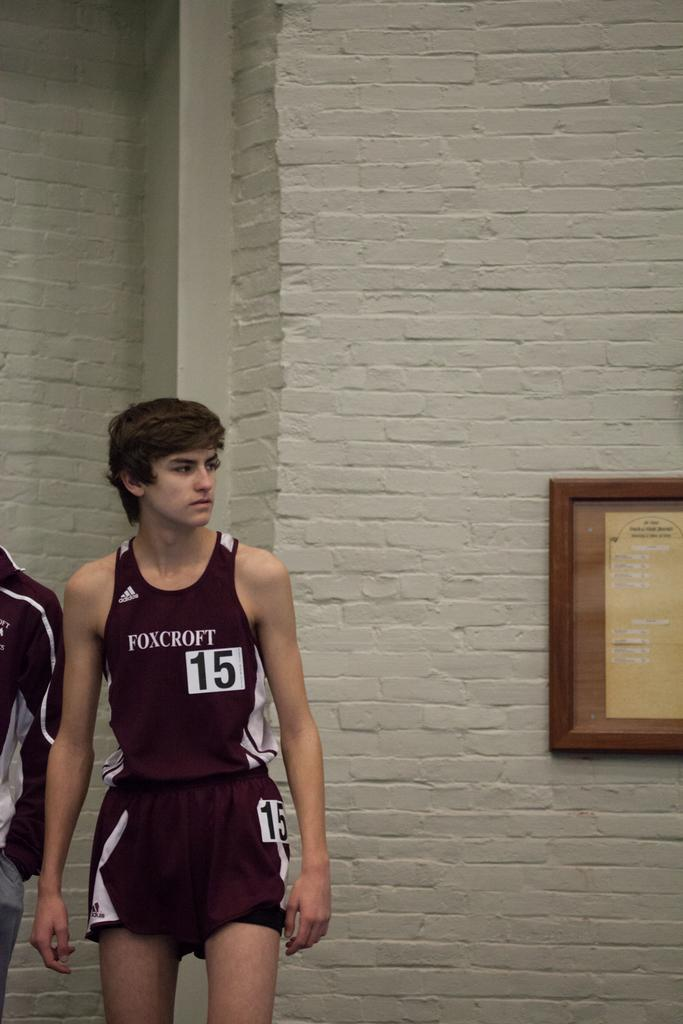Provide a one-sentence caption for the provided image. A boy wearing jersey number 15 for Foxcroft stands near a brick wall. 